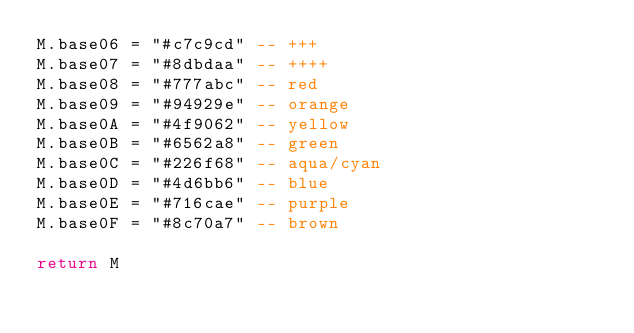Convert code to text. <code><loc_0><loc_0><loc_500><loc_500><_Lua_>M.base06 = "#c7c9cd" -- +++
M.base07 = "#8dbdaa" -- ++++
M.base08 = "#777abc" -- red
M.base09 = "#94929e" -- orange
M.base0A = "#4f9062" -- yellow
M.base0B = "#6562a8" -- green
M.base0C = "#226f68" -- aqua/cyan
M.base0D = "#4d6bb6" -- blue
M.base0E = "#716cae" -- purple
M.base0F = "#8c70a7" -- brown

return M
</code> 